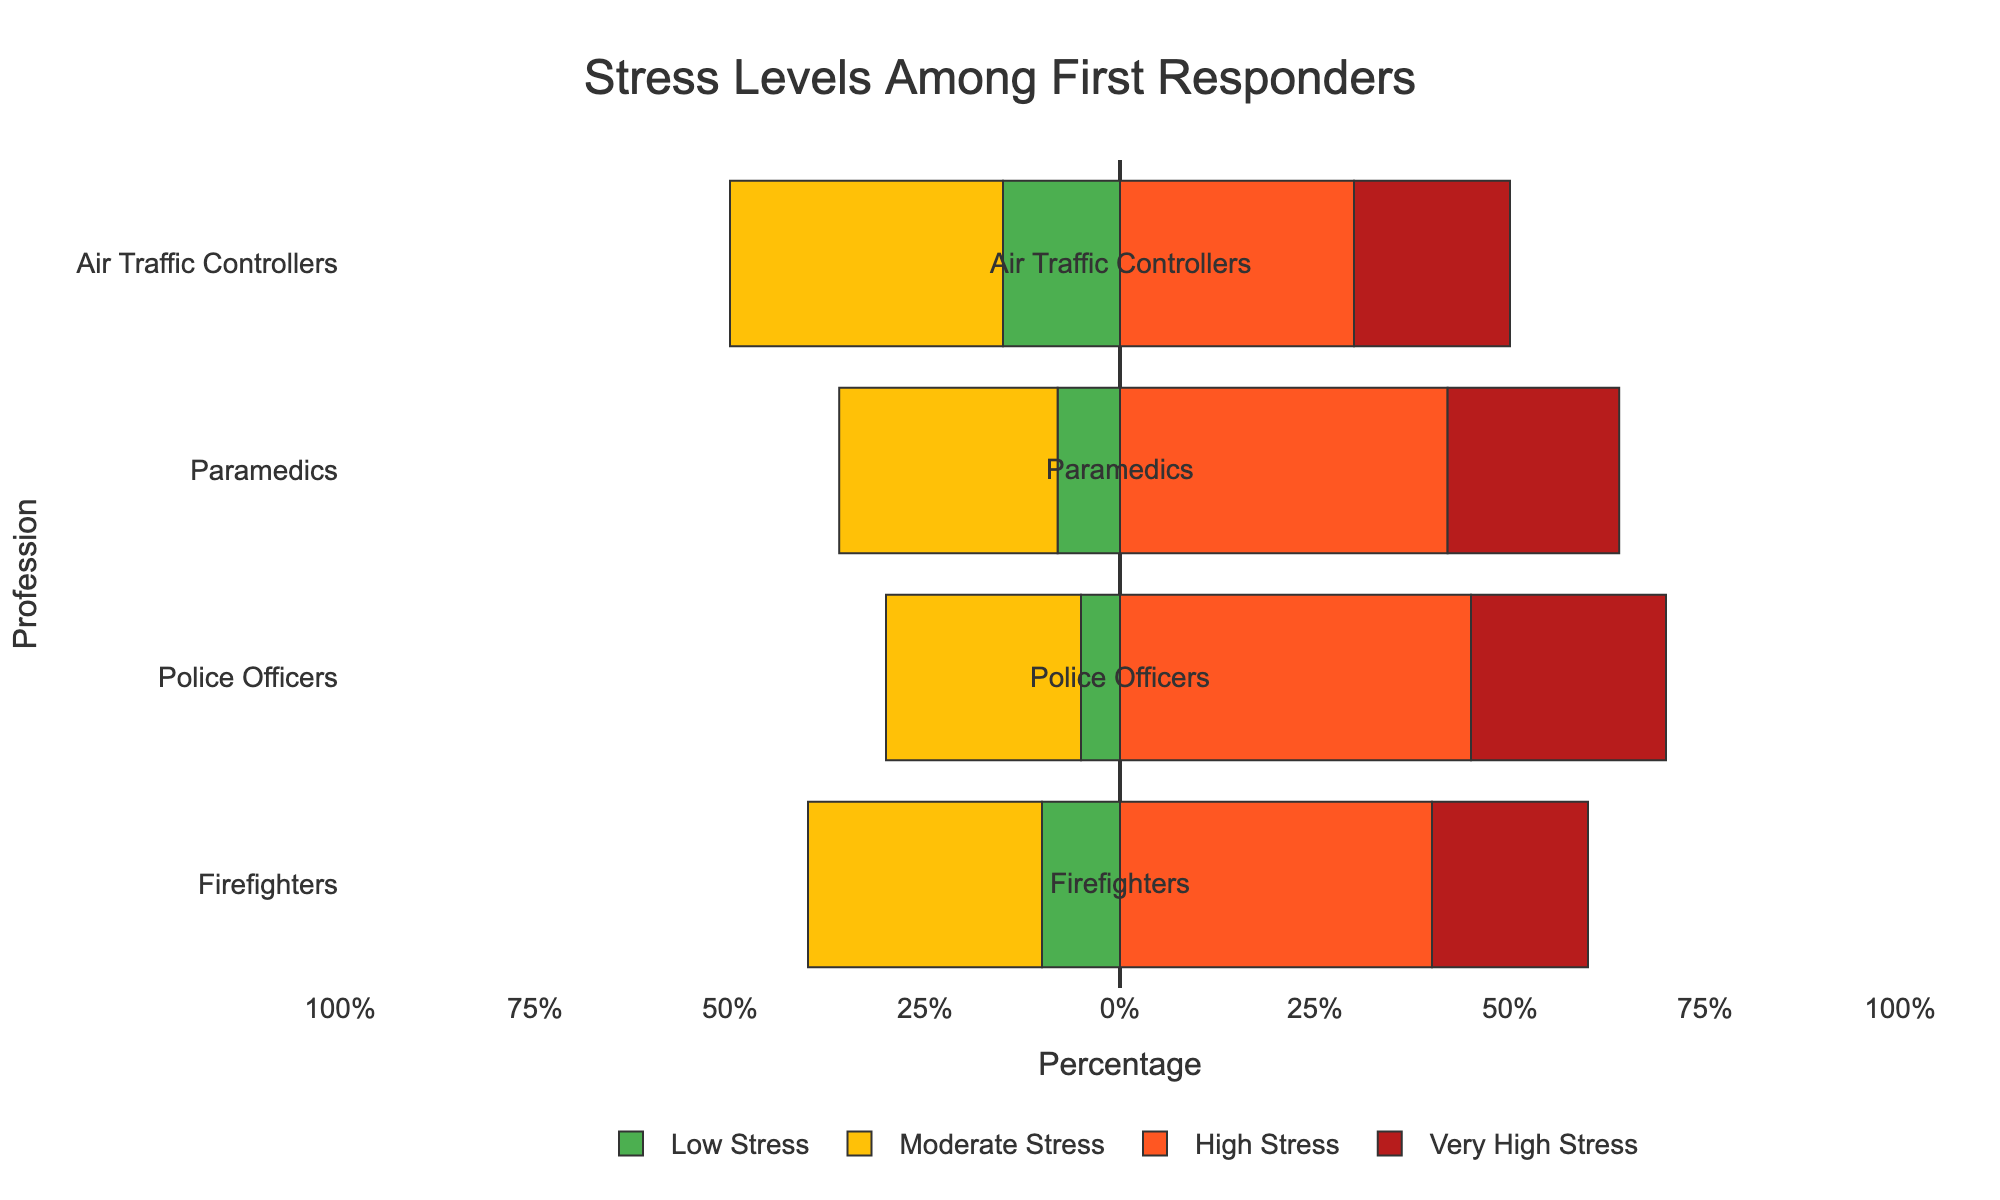How many percent of firefighters experience high or very high stress levels? To determine this, add the percentages of firefighters experiencing high stress (40%) and very high stress (20%), which gives 60%.
Answer: 60% Which profession has the highest percentage of individuals with low stress levels? Observe the lengths of the bars representing low stress levels for all professions. The air traffic controllers' green bar extends farthest, indicating they have the highest percentage at 15%.
Answer: Air Traffic Controllers How do the moderate stress levels of paramedics and air traffic controllers compare? Compare the lengths of the yellow bars representing moderate stress for both professions. Paramedics have 28%, and air traffic controllers have 35%. Thus, air traffic controllers have a higher moderate stress level.
Answer: Air Traffic Controllers Which profession has the highest percentage of individuals experiencing very high stress? Look for the longest red bar that represents very high stress. Police officers have the longest bar with a value of 25%.
Answer: Police Officers What is the difference in high stress levels between police officers and firefighters? Identify the high stress levels for both professions: police officers (45%) and firefighters (40%). The difference is 45% - 40% = 5%.
Answer: 5% What percentage of air traffic controllers experience moderate or higher stress levels? Add the percentages of air traffic controllers experiencing moderate (35%), high (30%), and very high stress (20%). The total is 35% + 30% + 20% = 85%.
Answer: 85% Which profession shows the lowest combined percentage of high and very high stress? Add the high and very high stress percentages for each profession and identify the lowest total. Air traffic controllers have 30% high and 20% very high, totaling 50%, which is the lowest.
Answer: Air Traffic Controllers How does the low stress level of firefighters compare to that of police officers and paramedics combined? Firefighters have 10% low stress. Police officers have 5%, and paramedics have 8%. Combined, police officers and paramedics have 5% + 8% = 13%. Thus, firefighters have 3% less low stress.
Answer: 3% less What is the combined percentage of individuals experiencing either low or high stress levels across all professions? Sum the low and high stress levels for each profession: Firefighters: 10% + 40% = 50%, Police Officers: 5% + 45% = 50%, Paramedics: 8% + 42% = 50%, Air Traffic Controllers: 15% + 30% = 45%. Add these totals: 50% + 50% + 50% + 45% = 195%.
Answer: 195% 